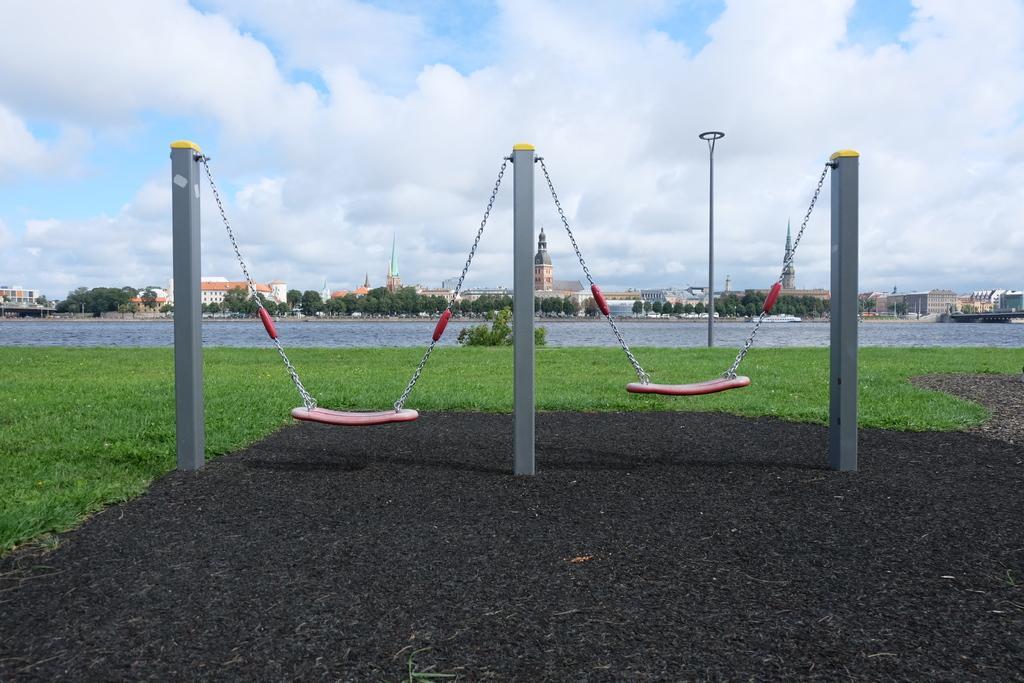Describe this image in one or two sentences. In the picture we can see a grass surface on it, we can see three poles and in the background, we can see the water surface, trees, buildings, and the sky with clouds. 